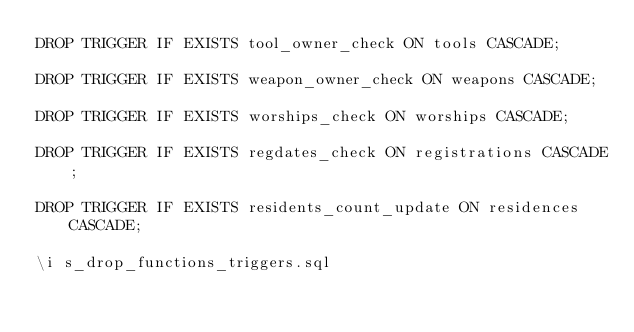<code> <loc_0><loc_0><loc_500><loc_500><_SQL_>DROP TRIGGER IF EXISTS tool_owner_check ON tools CASCADE;

DROP TRIGGER IF EXISTS weapon_owner_check ON weapons CASCADE;

DROP TRIGGER IF EXISTS worships_check ON worships CASCADE;

DROP TRIGGER IF EXISTS regdates_check ON registrations CASCADE;

DROP TRIGGER IF EXISTS residents_count_update ON residences CASCADE;

\i s_drop_functions_triggers.sql
</code> 